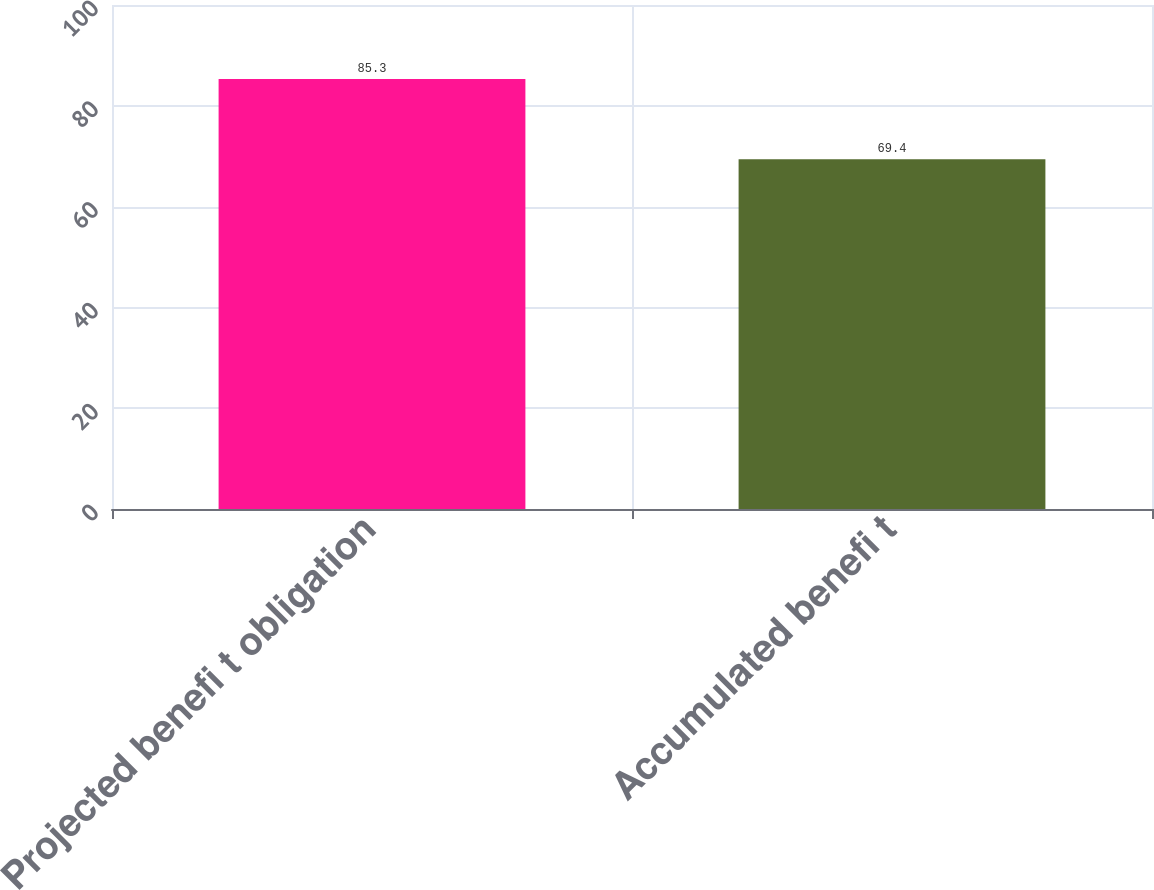Convert chart to OTSL. <chart><loc_0><loc_0><loc_500><loc_500><bar_chart><fcel>Projected benefi t obligation<fcel>Accumulated benefi t<nl><fcel>85.3<fcel>69.4<nl></chart> 